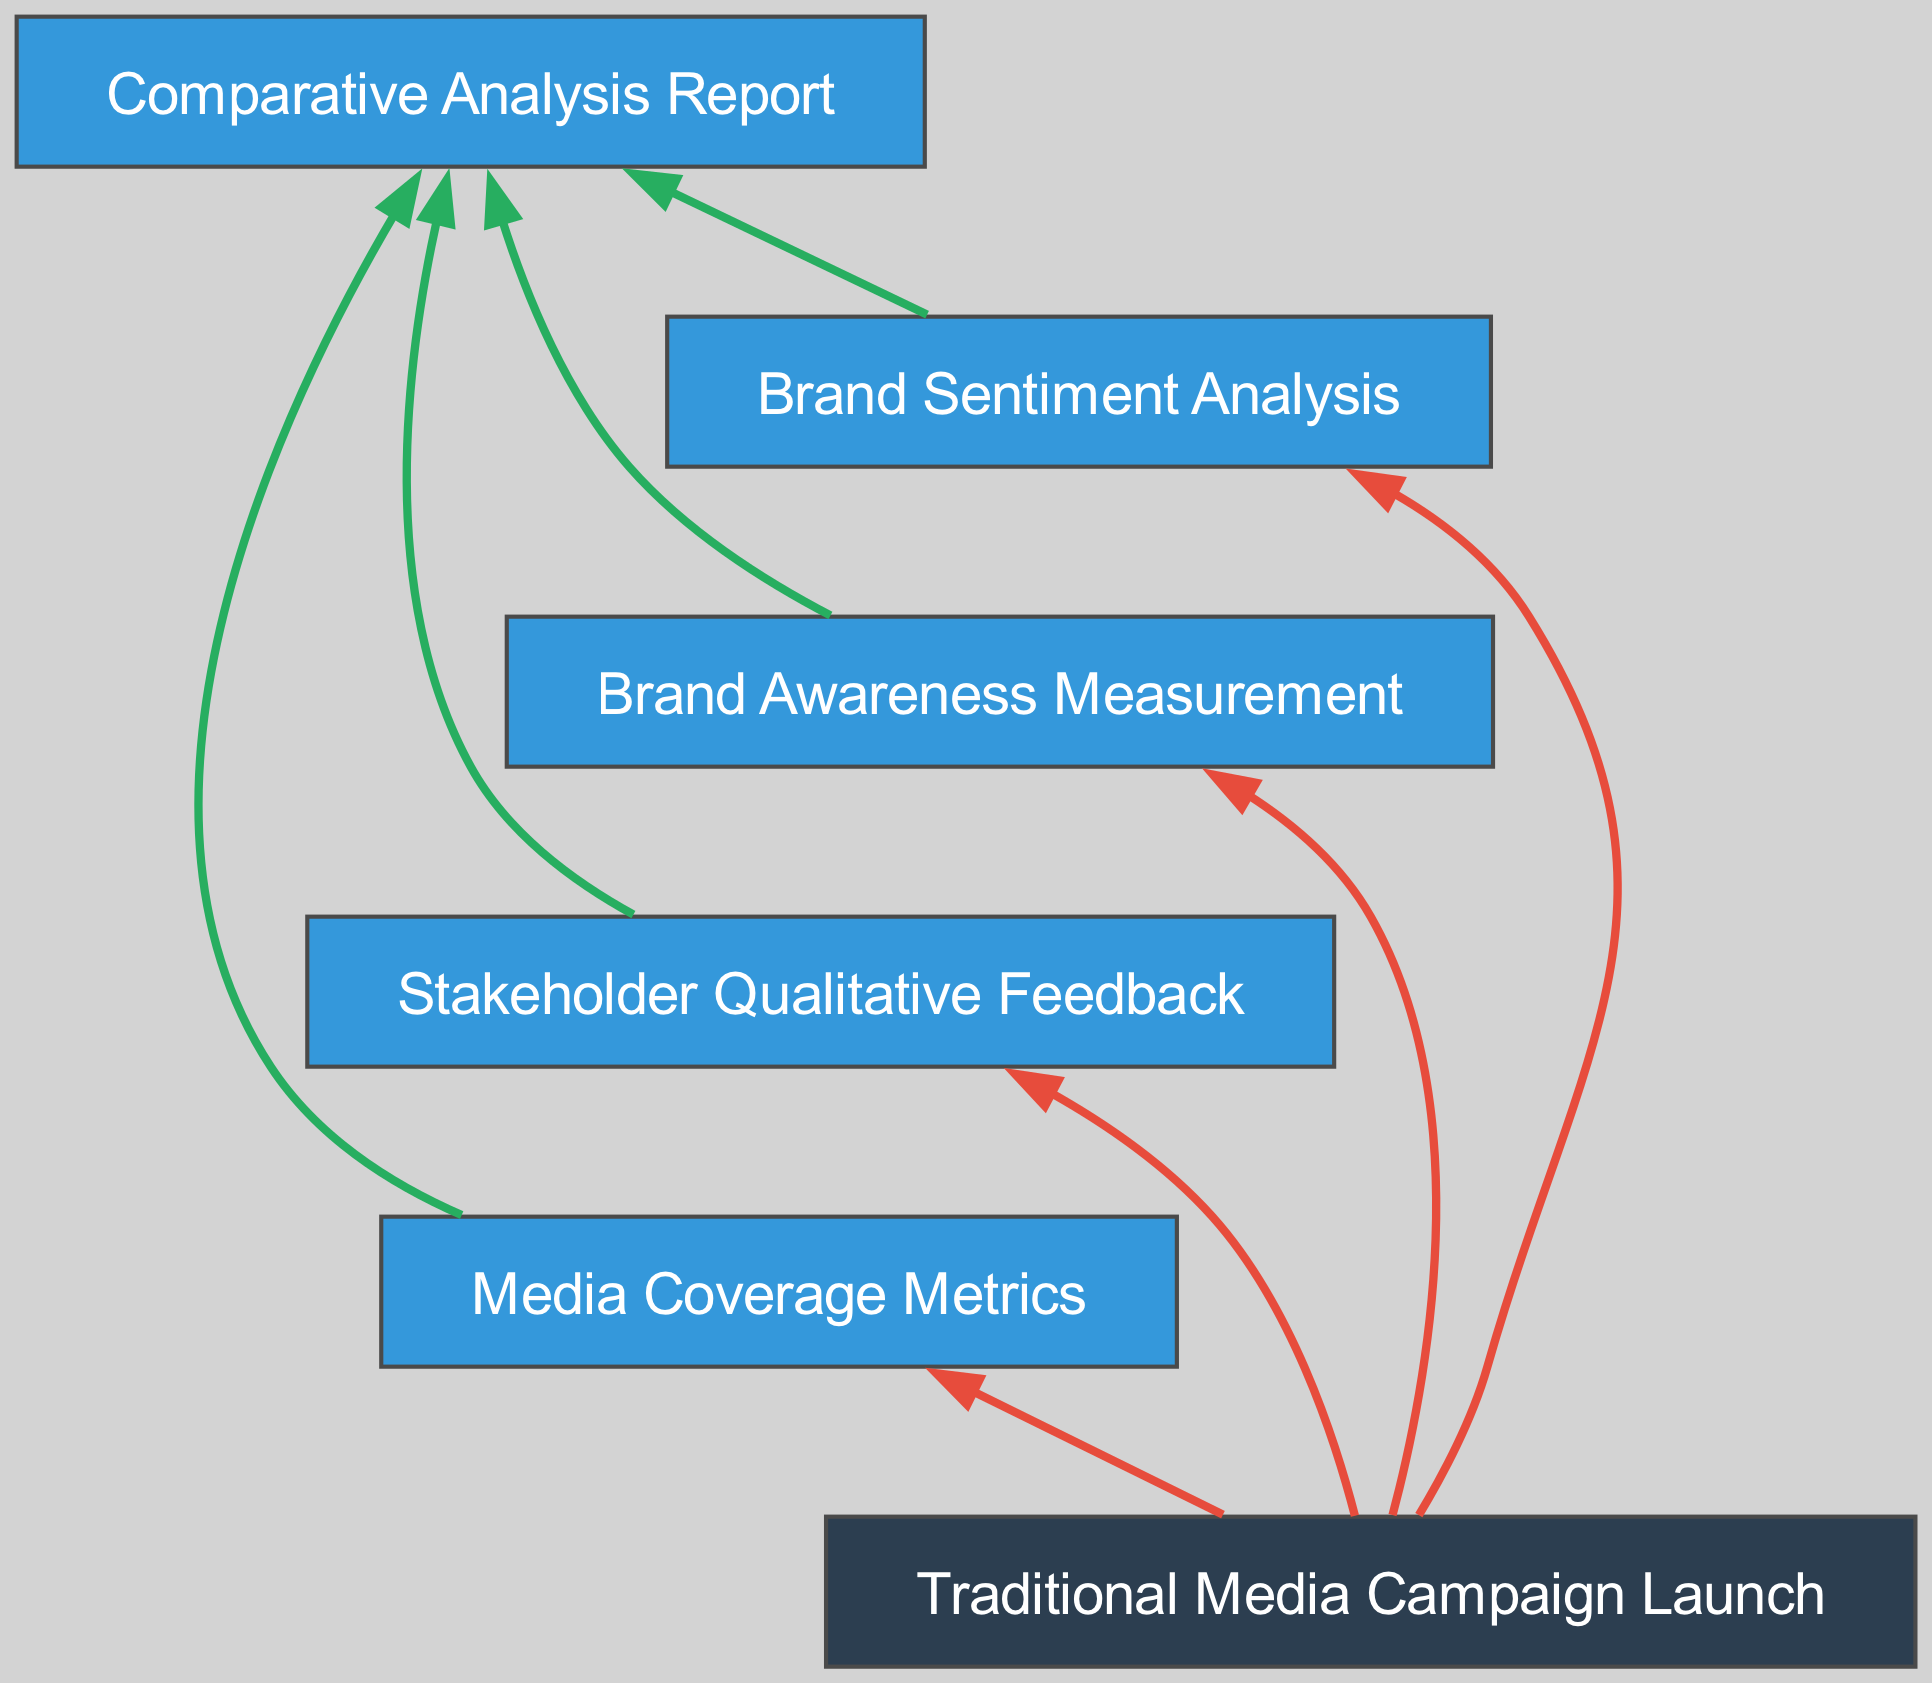What is the first step in the flow chart? The first step listed in the diagram is "Traditional Media Campaign Launch." This node represents the input to the process of evaluating brand perception shifts.
Answer: Traditional Media Campaign Launch How many output nodes are there? There are four output nodes in the diagram: "Media Coverage Metrics," "Stakeholder Qualitative Feedback," "Brand Awareness Measurement," and "Brand Sentiment Analysis." These output nodes show the results generated from the campaign launch.
Answer: 4 Which node connects directly to the "Comparative Analysis Report"? The "Comparative Analysis Report" node is connected directly by four other nodes: "Media Coverage Metrics," "Stakeholder Qualitative Feedback," "Brand Awareness Measurement," and "Brand Sentiment Analysis." This means each of these outputs contributes to the comprehensive report.
Answer: Four What type of data is gathered in the "Stakeholder Qualitative Feedback" node? The "Stakeholder Qualitative Feedback" node collects insights through focus groups, surveys, and interviews conducted after the campaign. It focuses on the qualitative aspect of stakeholder perception.
Answer: Qualitative insights What relationship exists between "Traditional Media Campaign Launch" and "Brand Sentiment Analysis"? The relationship is a one-way connection where "Traditional Media Campaign Launch" leads to the evaluation of "Brand Sentiment Analysis." This indicates that the launch initiates a process that influences brand sentiment through assessments.
Answer: One-way connection What is the color of the "Traditional Media Campaign Launch" node? The color of the "Traditional Media Campaign Launch" node is dark blue, which is used to signify input nodes in the diagram.
Answer: Dark blue How does the "Media Coverage Metrics" affect the overall analysis? The "Media Coverage Metrics" directly influences the "Comparative Analysis Report" by providing quantifiable data necessary for understanding the effectiveness of the campaign, thereby integrating its statistical results into the overall evaluation.
Answer: Provides quantifiable data Which node could potentially indicate a positive shift in brand perception? The "Brand Sentiment Analysis" node indicates a positive shift in brand perception by evaluating public sentiment through monitoring and feedback. Positive sentiment is a key indicator of perceived improvement in brand image after the campaign.
Answer: Brand Sentiment Analysis What type of edge connects "Traditional Media Campaign Launch" to the output nodes? The edges connecting "Traditional Media Campaign Launch" to the output nodes are colored red, which denotes a flow of influence from the input to the outputs, indicating that the launch directly facilitates the information flow to those outputs.
Answer: Red edges 